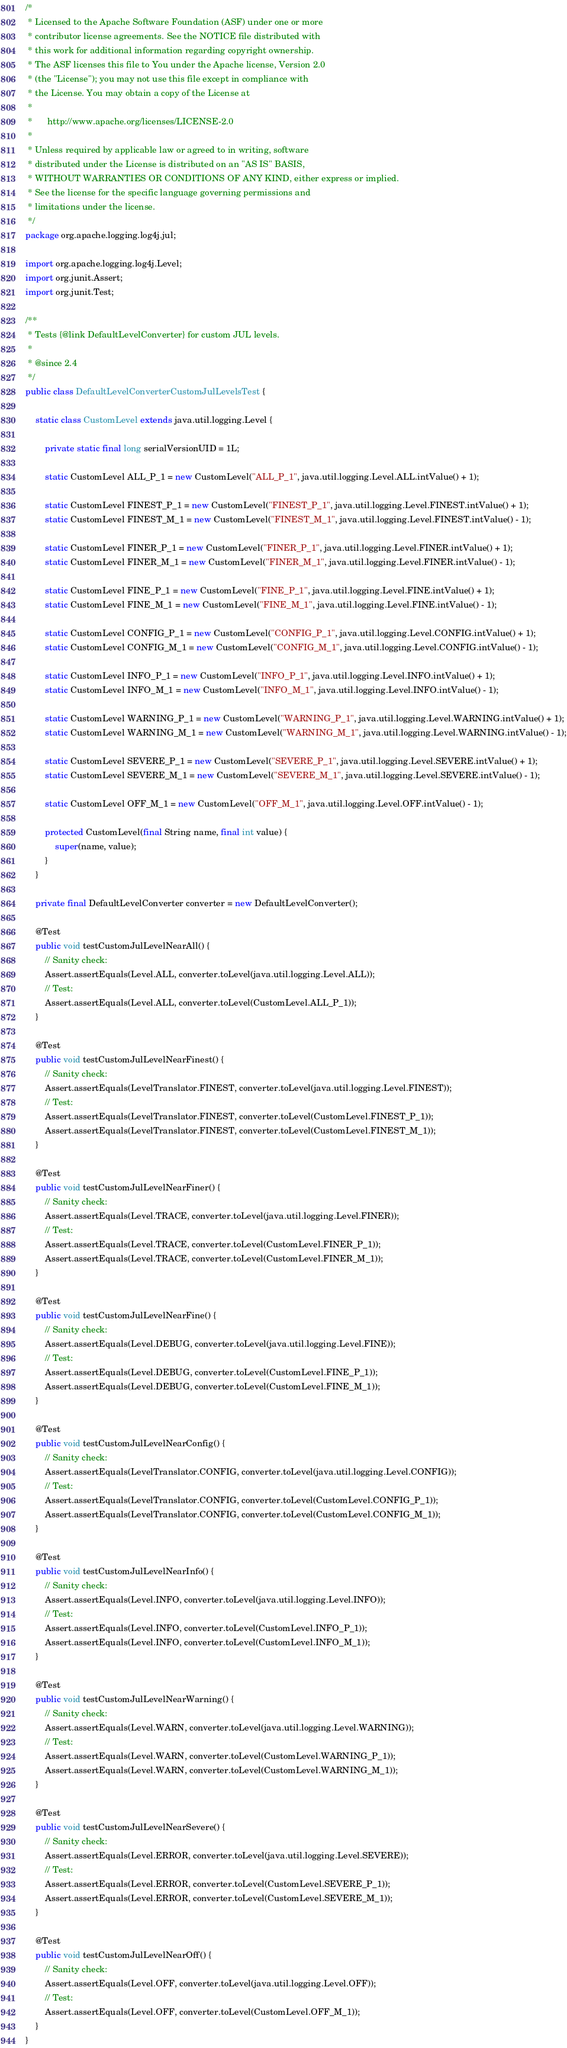Convert code to text. <code><loc_0><loc_0><loc_500><loc_500><_Java_>/*
 * Licensed to the Apache Software Foundation (ASF) under one or more
 * contributor license agreements. See the NOTICE file distributed with
 * this work for additional information regarding copyright ownership.
 * The ASF licenses this file to You under the Apache license, Version 2.0
 * (the "License"); you may not use this file except in compliance with
 * the License. You may obtain a copy of the License at
 *
 *      http://www.apache.org/licenses/LICENSE-2.0
 *
 * Unless required by applicable law or agreed to in writing, software
 * distributed under the License is distributed on an "AS IS" BASIS,
 * WITHOUT WARRANTIES OR CONDITIONS OF ANY KIND, either express or implied.
 * See the license for the specific language governing permissions and
 * limitations under the license.
 */
package org.apache.logging.log4j.jul;

import org.apache.logging.log4j.Level;
import org.junit.Assert;
import org.junit.Test;

/**
 * Tests {@link DefaultLevelConverter} for custom JUL levels.
 *
 * @since 2.4
 */
public class DefaultLevelConverterCustomJulLevelsTest {

    static class CustomLevel extends java.util.logging.Level {

        private static final long serialVersionUID = 1L;

        static CustomLevel ALL_P_1 = new CustomLevel("ALL_P_1", java.util.logging.Level.ALL.intValue() + 1);

        static CustomLevel FINEST_P_1 = new CustomLevel("FINEST_P_1", java.util.logging.Level.FINEST.intValue() + 1);
        static CustomLevel FINEST_M_1 = new CustomLevel("FINEST_M_1", java.util.logging.Level.FINEST.intValue() - 1);

        static CustomLevel FINER_P_1 = new CustomLevel("FINER_P_1", java.util.logging.Level.FINER.intValue() + 1);
        static CustomLevel FINER_M_1 = new CustomLevel("FINER_M_1", java.util.logging.Level.FINER.intValue() - 1);

        static CustomLevel FINE_P_1 = new CustomLevel("FINE_P_1", java.util.logging.Level.FINE.intValue() + 1);
        static CustomLevel FINE_M_1 = new CustomLevel("FINE_M_1", java.util.logging.Level.FINE.intValue() - 1);

        static CustomLevel CONFIG_P_1 = new CustomLevel("CONFIG_P_1", java.util.logging.Level.CONFIG.intValue() + 1);
        static CustomLevel CONFIG_M_1 = new CustomLevel("CONFIG_M_1", java.util.logging.Level.CONFIG.intValue() - 1);

        static CustomLevel INFO_P_1 = new CustomLevel("INFO_P_1", java.util.logging.Level.INFO.intValue() + 1);
        static CustomLevel INFO_M_1 = new CustomLevel("INFO_M_1", java.util.logging.Level.INFO.intValue() - 1);

        static CustomLevel WARNING_P_1 = new CustomLevel("WARNING_P_1", java.util.logging.Level.WARNING.intValue() + 1);
        static CustomLevel WARNING_M_1 = new CustomLevel("WARNING_M_1", java.util.logging.Level.WARNING.intValue() - 1);

        static CustomLevel SEVERE_P_1 = new CustomLevel("SEVERE_P_1", java.util.logging.Level.SEVERE.intValue() + 1);
        static CustomLevel SEVERE_M_1 = new CustomLevel("SEVERE_M_1", java.util.logging.Level.SEVERE.intValue() - 1);

        static CustomLevel OFF_M_1 = new CustomLevel("OFF_M_1", java.util.logging.Level.OFF.intValue() - 1);

        protected CustomLevel(final String name, final int value) {
            super(name, value);
        }
    }

    private final DefaultLevelConverter converter = new DefaultLevelConverter();

    @Test
    public void testCustomJulLevelNearAll() {
        // Sanity check:
        Assert.assertEquals(Level.ALL, converter.toLevel(java.util.logging.Level.ALL));
        // Test:
        Assert.assertEquals(Level.ALL, converter.toLevel(CustomLevel.ALL_P_1));
    }

    @Test
    public void testCustomJulLevelNearFinest() {
        // Sanity check:
        Assert.assertEquals(LevelTranslator.FINEST, converter.toLevel(java.util.logging.Level.FINEST));
        // Test:
        Assert.assertEquals(LevelTranslator.FINEST, converter.toLevel(CustomLevel.FINEST_P_1));
        Assert.assertEquals(LevelTranslator.FINEST, converter.toLevel(CustomLevel.FINEST_M_1));
    }

    @Test
    public void testCustomJulLevelNearFiner() {
        // Sanity check:
        Assert.assertEquals(Level.TRACE, converter.toLevel(java.util.logging.Level.FINER));
        // Test:
        Assert.assertEquals(Level.TRACE, converter.toLevel(CustomLevel.FINER_P_1));
        Assert.assertEquals(Level.TRACE, converter.toLevel(CustomLevel.FINER_M_1));
    }

    @Test
    public void testCustomJulLevelNearFine() {
        // Sanity check:
        Assert.assertEquals(Level.DEBUG, converter.toLevel(java.util.logging.Level.FINE));
        // Test:
        Assert.assertEquals(Level.DEBUG, converter.toLevel(CustomLevel.FINE_P_1));
        Assert.assertEquals(Level.DEBUG, converter.toLevel(CustomLevel.FINE_M_1));
    }

    @Test
    public void testCustomJulLevelNearConfig() {
        // Sanity check:
        Assert.assertEquals(LevelTranslator.CONFIG, converter.toLevel(java.util.logging.Level.CONFIG));
        // Test:
        Assert.assertEquals(LevelTranslator.CONFIG, converter.toLevel(CustomLevel.CONFIG_P_1));
        Assert.assertEquals(LevelTranslator.CONFIG, converter.toLevel(CustomLevel.CONFIG_M_1));
    }

    @Test
    public void testCustomJulLevelNearInfo() {
        // Sanity check:
        Assert.assertEquals(Level.INFO, converter.toLevel(java.util.logging.Level.INFO));
        // Test:
        Assert.assertEquals(Level.INFO, converter.toLevel(CustomLevel.INFO_P_1));
        Assert.assertEquals(Level.INFO, converter.toLevel(CustomLevel.INFO_M_1));
    }

    @Test
    public void testCustomJulLevelNearWarning() {
        // Sanity check:
        Assert.assertEquals(Level.WARN, converter.toLevel(java.util.logging.Level.WARNING));
        // Test:
        Assert.assertEquals(Level.WARN, converter.toLevel(CustomLevel.WARNING_P_1));
        Assert.assertEquals(Level.WARN, converter.toLevel(CustomLevel.WARNING_M_1));
    }

    @Test
    public void testCustomJulLevelNearSevere() {
        // Sanity check:
        Assert.assertEquals(Level.ERROR, converter.toLevel(java.util.logging.Level.SEVERE));
        // Test:
        Assert.assertEquals(Level.ERROR, converter.toLevel(CustomLevel.SEVERE_P_1));
        Assert.assertEquals(Level.ERROR, converter.toLevel(CustomLevel.SEVERE_M_1));
    }

    @Test
    public void testCustomJulLevelNearOff() {
        // Sanity check:
        Assert.assertEquals(Level.OFF, converter.toLevel(java.util.logging.Level.OFF));
        // Test:
        Assert.assertEquals(Level.OFF, converter.toLevel(CustomLevel.OFF_M_1));
    }
}
</code> 